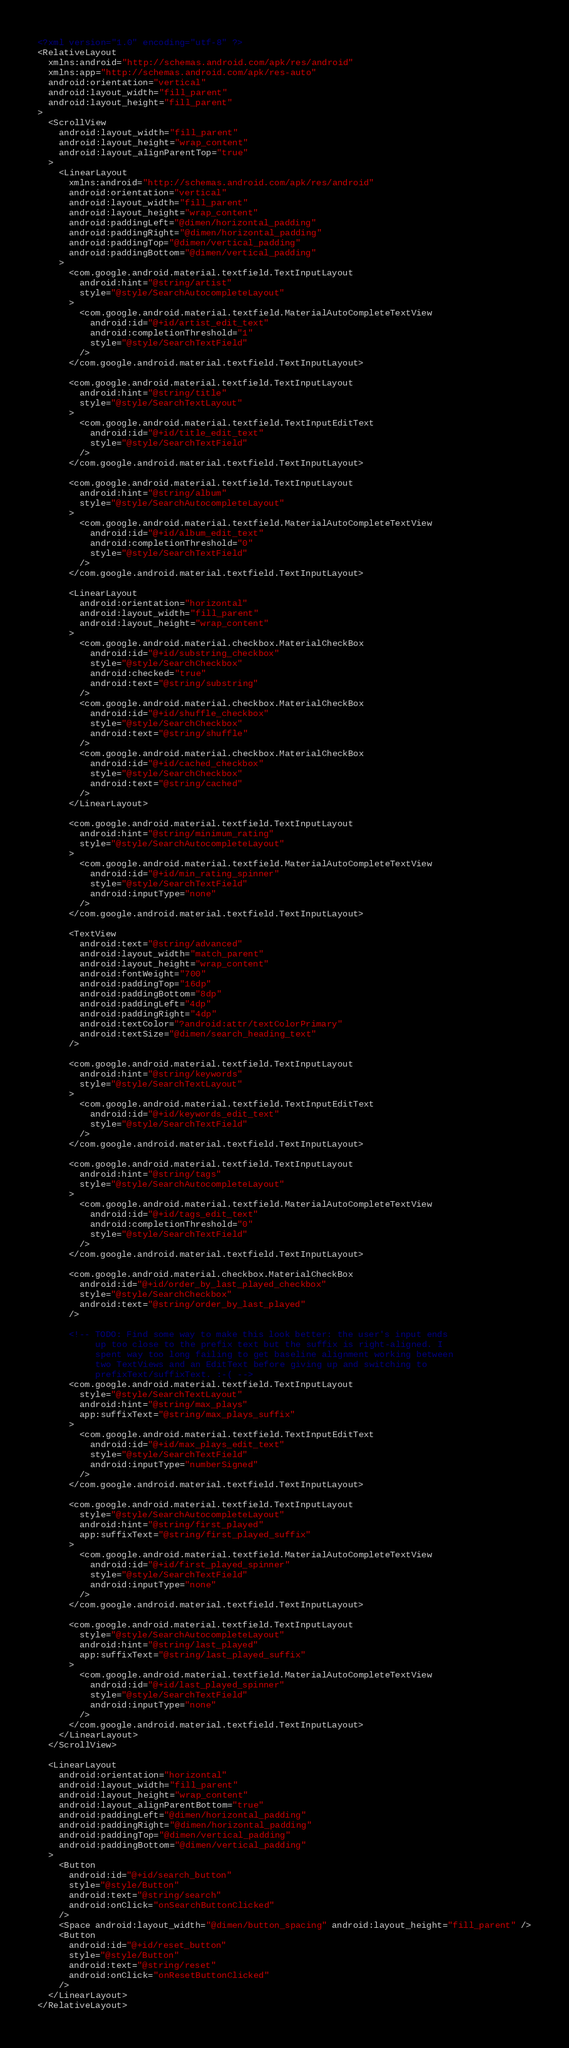<code> <loc_0><loc_0><loc_500><loc_500><_XML_><?xml version="1.0" encoding="utf-8" ?>
<RelativeLayout
  xmlns:android="http://schemas.android.com/apk/res/android"
  xmlns:app="http://schemas.android.com/apk/res-auto"
  android:orientation="vertical"
  android:layout_width="fill_parent"
  android:layout_height="fill_parent"
>
  <ScrollView
    android:layout_width="fill_parent"
    android:layout_height="wrap_content"
    android:layout_alignParentTop="true"
  >
    <LinearLayout
      xmlns:android="http://schemas.android.com/apk/res/android"
      android:orientation="vertical"
      android:layout_width="fill_parent"
      android:layout_height="wrap_content"
      android:paddingLeft="@dimen/horizontal_padding"
      android:paddingRight="@dimen/horizontal_padding"
      android:paddingTop="@dimen/vertical_padding"
      android:paddingBottom="@dimen/vertical_padding"
    >
      <com.google.android.material.textfield.TextInputLayout
        android:hint="@string/artist"
        style="@style/SearchAutocompleteLayout"
      >
        <com.google.android.material.textfield.MaterialAutoCompleteTextView
          android:id="@+id/artist_edit_text"
          android:completionThreshold="1"
          style="@style/SearchTextField"
        />
      </com.google.android.material.textfield.TextInputLayout>

      <com.google.android.material.textfield.TextInputLayout
        android:hint="@string/title"
        style="@style/SearchTextLayout"
      >
        <com.google.android.material.textfield.TextInputEditText
          android:id="@+id/title_edit_text"
          style="@style/SearchTextField"
        />
      </com.google.android.material.textfield.TextInputLayout>

      <com.google.android.material.textfield.TextInputLayout
        android:hint="@string/album"
        style="@style/SearchAutocompleteLayout"
      >
        <com.google.android.material.textfield.MaterialAutoCompleteTextView
          android:id="@+id/album_edit_text"
          android:completionThreshold="0"
          style="@style/SearchTextField"
        />
      </com.google.android.material.textfield.TextInputLayout>

      <LinearLayout
        android:orientation="horizontal"
        android:layout_width="fill_parent"
        android:layout_height="wrap_content"
      >
        <com.google.android.material.checkbox.MaterialCheckBox
          android:id="@+id/substring_checkbox"
          style="@style/SearchCheckbox"
          android:checked="true"
          android:text="@string/substring"
        />
        <com.google.android.material.checkbox.MaterialCheckBox
          android:id="@+id/shuffle_checkbox"
          style="@style/SearchCheckbox"
          android:text="@string/shuffle"
        />
        <com.google.android.material.checkbox.MaterialCheckBox
          android:id="@+id/cached_checkbox"
          style="@style/SearchCheckbox"
          android:text="@string/cached"
        />
      </LinearLayout>

      <com.google.android.material.textfield.TextInputLayout
        android:hint="@string/minimum_rating"
        style="@style/SearchAutocompleteLayout"
      >
        <com.google.android.material.textfield.MaterialAutoCompleteTextView
          android:id="@+id/min_rating_spinner"
          style="@style/SearchTextField"
          android:inputType="none"
        />
      </com.google.android.material.textfield.TextInputLayout>

      <TextView
        android:text="@string/advanced"
        android:layout_width="match_parent"
        android:layout_height="wrap_content"
        android:fontWeight="700"
        android:paddingTop="16dp"
        android:paddingBottom="8dp"
        android:paddingLeft="4dp"
        android:paddingRight="4dp"
        android:textColor="?android:attr/textColorPrimary"
        android:textSize="@dimen/search_heading_text"
      />

      <com.google.android.material.textfield.TextInputLayout
        android:hint="@string/keywords"
        style="@style/SearchTextLayout"
      >
        <com.google.android.material.textfield.TextInputEditText
          android:id="@+id/keywords_edit_text"
          style="@style/SearchTextField"
        />
      </com.google.android.material.textfield.TextInputLayout>

      <com.google.android.material.textfield.TextInputLayout
        android:hint="@string/tags"
        style="@style/SearchAutocompleteLayout"
      >
        <com.google.android.material.textfield.MaterialAutoCompleteTextView
          android:id="@+id/tags_edit_text"
          android:completionThreshold="0"
          style="@style/SearchTextField"
        />
      </com.google.android.material.textfield.TextInputLayout>

      <com.google.android.material.checkbox.MaterialCheckBox
        android:id="@+id/order_by_last_played_checkbox"
        style="@style/SearchCheckbox"
        android:text="@string/order_by_last_played"
      />

      <!-- TODO: Find some way to make this look better: the user's input ends
           up too close to the prefix text but the suffix is right-aligned. I
           spent way too long failing to get baseline alignment working between
           two TextViews and an EditText before giving up and switching to
           prefixText/suffixText. :-( -->
      <com.google.android.material.textfield.TextInputLayout
        style="@style/SearchTextLayout"
        android:hint="@string/max_plays"
        app:suffixText="@string/max_plays_suffix"
      >
        <com.google.android.material.textfield.TextInputEditText
          android:id="@+id/max_plays_edit_text"
          style="@style/SearchTextField"
          android:inputType="numberSigned"
        />
      </com.google.android.material.textfield.TextInputLayout>

      <com.google.android.material.textfield.TextInputLayout
        style="@style/SearchAutocompleteLayout"
        android:hint="@string/first_played"
        app:suffixText="@string/first_played_suffix"
      >
        <com.google.android.material.textfield.MaterialAutoCompleteTextView
          android:id="@+id/first_played_spinner"
          style="@style/SearchTextField"
          android:inputType="none"
        />
      </com.google.android.material.textfield.TextInputLayout>

      <com.google.android.material.textfield.TextInputLayout
        style="@style/SearchAutocompleteLayout"
        android:hint="@string/last_played"
        app:suffixText="@string/last_played_suffix"
      >
        <com.google.android.material.textfield.MaterialAutoCompleteTextView
          android:id="@+id/last_played_spinner"
          style="@style/SearchTextField"
          android:inputType="none"
        />
      </com.google.android.material.textfield.TextInputLayout>
    </LinearLayout>
  </ScrollView>

  <LinearLayout
    android:orientation="horizontal"
    android:layout_width="fill_parent"
    android:layout_height="wrap_content"
    android:layout_alignParentBottom="true"
    android:paddingLeft="@dimen/horizontal_padding"
    android:paddingRight="@dimen/horizontal_padding"
    android:paddingTop="@dimen/vertical_padding"
    android:paddingBottom="@dimen/vertical_padding"
  >
    <Button
      android:id="@+id/search_button"
      style="@style/Button"
      android:text="@string/search"
      android:onClick="onSearchButtonClicked"
    />
    <Space android:layout_width="@dimen/button_spacing" android:layout_height="fill_parent" />
    <Button
      android:id="@+id/reset_button"
      style="@style/Button"
      android:text="@string/reset"
      android:onClick="onResetButtonClicked"
    />
  </LinearLayout>
</RelativeLayout>
</code> 